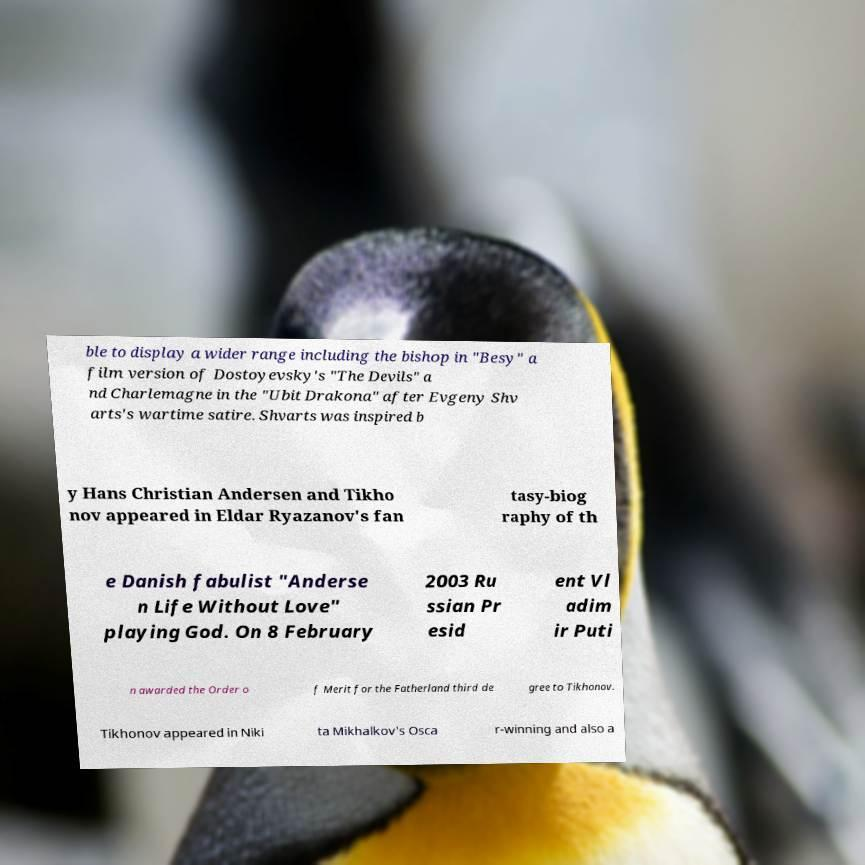Could you assist in decoding the text presented in this image and type it out clearly? ble to display a wider range including the bishop in "Besy" a film version of Dostoyevsky's "The Devils" a nd Charlemagne in the "Ubit Drakona" after Evgeny Shv arts's wartime satire. Shvarts was inspired b y Hans Christian Andersen and Tikho nov appeared in Eldar Ryazanov's fan tasy-biog raphy of th e Danish fabulist "Anderse n Life Without Love" playing God. On 8 February 2003 Ru ssian Pr esid ent Vl adim ir Puti n awarded the Order o f Merit for the Fatherland third de gree to Tikhonov. Tikhonov appeared in Niki ta Mikhalkov's Osca r-winning and also a 